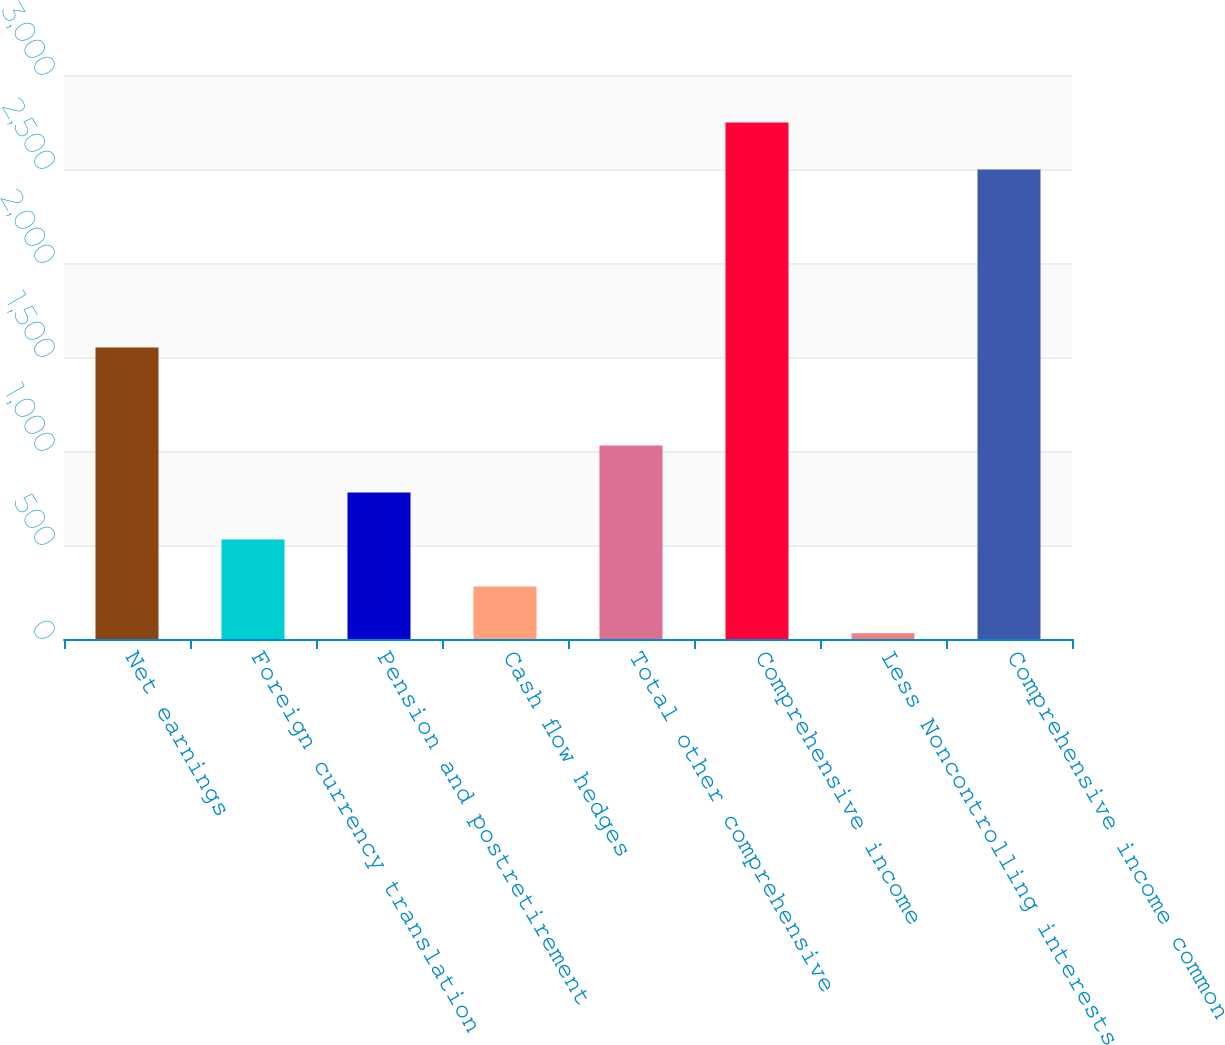<chart> <loc_0><loc_0><loc_500><loc_500><bar_chart><fcel>Net earnings<fcel>Foreign currency translation<fcel>Pension and postretirement<fcel>Cash flow hedges<fcel>Total other comprehensive<fcel>Comprehensive income<fcel>Less Noncontrolling interests<fcel>Comprehensive income common<nl><fcel>1550<fcel>529.6<fcel>779.4<fcel>279.8<fcel>1029.2<fcel>2747.8<fcel>30<fcel>2498<nl></chart> 